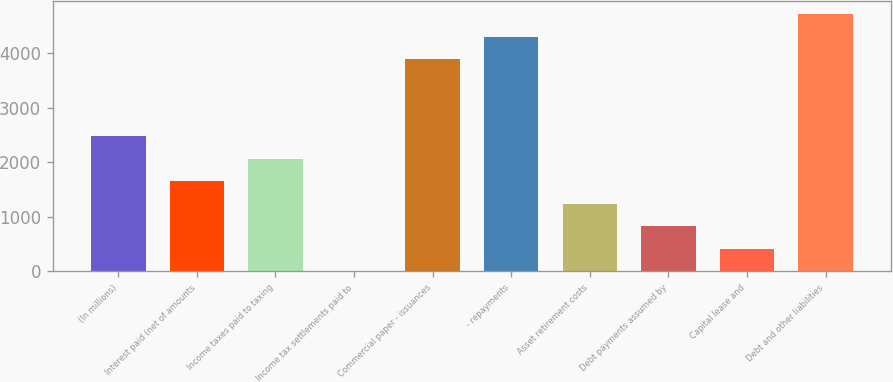<chart> <loc_0><loc_0><loc_500><loc_500><bar_chart><fcel>(In millions)<fcel>Interest paid (net of amounts<fcel>Income taxes paid to taxing<fcel>Income tax settlements paid to<fcel>Commercial paper - issuances<fcel>- repayments<fcel>Asset retirement costs<fcel>Debt payments assumed by<fcel>Capital lease and<fcel>Debt and other liabilities<nl><fcel>2477.4<fcel>1653.6<fcel>2065.5<fcel>6<fcel>3896<fcel>4307.9<fcel>1241.7<fcel>829.8<fcel>417.9<fcel>4719.8<nl></chart> 